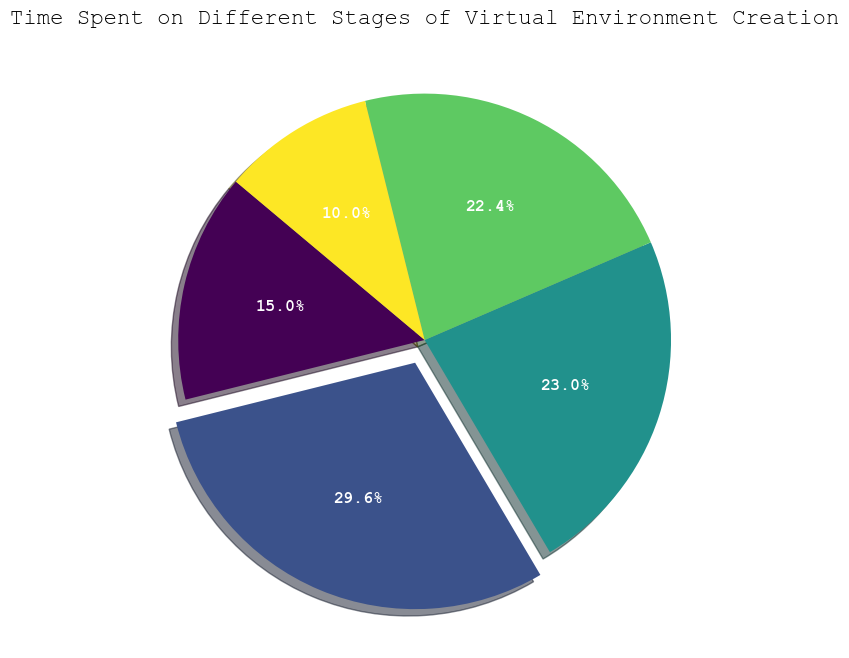What's the largest slice in the pie chart? First, find the largest percentage shown in the figure. The exploded slice typically represents the largest category, which is 'Modeling'.
Answer: Modeling What percentage of time is spent on 'Final Rendering'? Locate the 'Final Rendering' slice on the chart and read the percentage displayed on it.
Answer: 10% What's the combined percentage of time spent on 'Concept Design' and 'Lighting'? Find the individual percentages for 'Concept Design' and 'Lighting' from the pie chart. Sum these values: 17.6% (Concept Design) + 22.8% (Lighting) = 40.4%
Answer: 40.4% Which stage has the smallest percentage of time spent, and what is it? Identify the smallest slice on the chart and read its label and percentage. It's the 'Final Rendering' stage with 10%.
Answer: Final Rendering, 10% How does the percentage of time spent on 'Texturing' compare to 'Concept Design'? Find the individual percentages for 'Texturing' and 'Concept Design'. Compare 23.2% (Texturing) to 17.6% (Concept Design). 'Texturing' has a higher percentage.
Answer: Texturing has a higher percentage Is the percentage of time spent on 'Modeling' greater than or equal to 30%? Look at the percentage value of the 'Modeling' slice, which is 29.6%. This value is not greater than or equal to 30%.
Answer: No If 'Lighting' and 'Final Rendering' were merged into a single category, what would be the new percentage? Find the percentages of 'Lighting' and 'Final Rendering'. Sum these values: 22.8% (Lighting) + 10% (Final Rendering) = 32.8%
Answer: 32.8% Which two stages together take up around half of the total time spent? Identify pairs of stages and sum their percentages. 'Texturing' (23.2%) + 'Lighting' (22.8%) = 46%, which is close to half.
Answer: Texturing and Lighting 